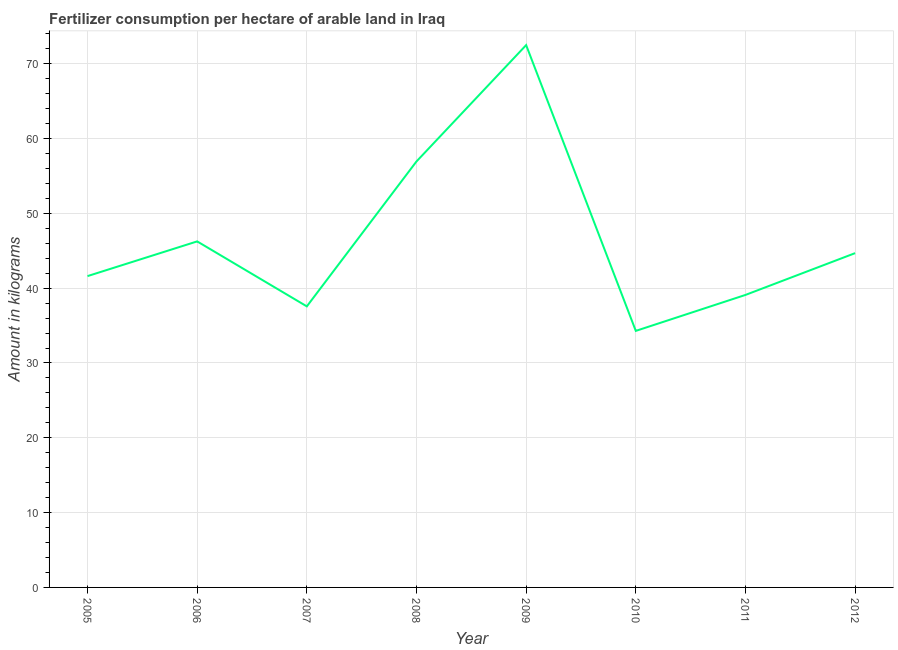What is the amount of fertilizer consumption in 2012?
Your response must be concise. 44.68. Across all years, what is the maximum amount of fertilizer consumption?
Provide a short and direct response. 72.49. Across all years, what is the minimum amount of fertilizer consumption?
Offer a terse response. 34.29. In which year was the amount of fertilizer consumption minimum?
Ensure brevity in your answer.  2010. What is the sum of the amount of fertilizer consumption?
Make the answer very short. 372.94. What is the difference between the amount of fertilizer consumption in 2008 and 2010?
Your answer should be very brief. 22.65. What is the average amount of fertilizer consumption per year?
Keep it short and to the point. 46.62. What is the median amount of fertilizer consumption?
Your response must be concise. 43.15. In how many years, is the amount of fertilizer consumption greater than 46 kg?
Provide a succinct answer. 3. What is the ratio of the amount of fertilizer consumption in 2010 to that in 2012?
Keep it short and to the point. 0.77. Is the amount of fertilizer consumption in 2005 less than that in 2010?
Your answer should be very brief. No. Is the difference between the amount of fertilizer consumption in 2006 and 2009 greater than the difference between any two years?
Your answer should be compact. No. What is the difference between the highest and the second highest amount of fertilizer consumption?
Give a very brief answer. 15.55. What is the difference between the highest and the lowest amount of fertilizer consumption?
Offer a terse response. 38.2. Does the amount of fertilizer consumption monotonically increase over the years?
Provide a succinct answer. No. How many lines are there?
Offer a very short reply. 1. What is the difference between two consecutive major ticks on the Y-axis?
Offer a very short reply. 10. Are the values on the major ticks of Y-axis written in scientific E-notation?
Make the answer very short. No. Does the graph contain any zero values?
Give a very brief answer. No. Does the graph contain grids?
Make the answer very short. Yes. What is the title of the graph?
Your answer should be compact. Fertilizer consumption per hectare of arable land in Iraq . What is the label or title of the Y-axis?
Ensure brevity in your answer.  Amount in kilograms. What is the Amount in kilograms in 2005?
Your answer should be compact. 41.61. What is the Amount in kilograms in 2006?
Keep it short and to the point. 46.25. What is the Amount in kilograms in 2007?
Offer a terse response. 37.57. What is the Amount in kilograms in 2008?
Your answer should be compact. 56.94. What is the Amount in kilograms of 2009?
Make the answer very short. 72.49. What is the Amount in kilograms of 2010?
Keep it short and to the point. 34.29. What is the Amount in kilograms in 2011?
Keep it short and to the point. 39.1. What is the Amount in kilograms in 2012?
Give a very brief answer. 44.68. What is the difference between the Amount in kilograms in 2005 and 2006?
Your response must be concise. -4.64. What is the difference between the Amount in kilograms in 2005 and 2007?
Provide a short and direct response. 4.05. What is the difference between the Amount in kilograms in 2005 and 2008?
Provide a short and direct response. -15.33. What is the difference between the Amount in kilograms in 2005 and 2009?
Your answer should be compact. -30.88. What is the difference between the Amount in kilograms in 2005 and 2010?
Provide a succinct answer. 7.32. What is the difference between the Amount in kilograms in 2005 and 2011?
Your answer should be compact. 2.52. What is the difference between the Amount in kilograms in 2005 and 2012?
Offer a very short reply. -3.07. What is the difference between the Amount in kilograms in 2006 and 2007?
Offer a very short reply. 8.69. What is the difference between the Amount in kilograms in 2006 and 2008?
Keep it short and to the point. -10.69. What is the difference between the Amount in kilograms in 2006 and 2009?
Offer a very short reply. -26.24. What is the difference between the Amount in kilograms in 2006 and 2010?
Your answer should be compact. 11.96. What is the difference between the Amount in kilograms in 2006 and 2011?
Offer a terse response. 7.16. What is the difference between the Amount in kilograms in 2006 and 2012?
Your answer should be very brief. 1.57. What is the difference between the Amount in kilograms in 2007 and 2008?
Provide a short and direct response. -19.37. What is the difference between the Amount in kilograms in 2007 and 2009?
Offer a terse response. -34.92. What is the difference between the Amount in kilograms in 2007 and 2010?
Provide a short and direct response. 3.28. What is the difference between the Amount in kilograms in 2007 and 2011?
Your answer should be very brief. -1.53. What is the difference between the Amount in kilograms in 2007 and 2012?
Ensure brevity in your answer.  -7.12. What is the difference between the Amount in kilograms in 2008 and 2009?
Give a very brief answer. -15.55. What is the difference between the Amount in kilograms in 2008 and 2010?
Offer a terse response. 22.65. What is the difference between the Amount in kilograms in 2008 and 2011?
Make the answer very short. 17.84. What is the difference between the Amount in kilograms in 2008 and 2012?
Keep it short and to the point. 12.26. What is the difference between the Amount in kilograms in 2009 and 2010?
Your answer should be compact. 38.2. What is the difference between the Amount in kilograms in 2009 and 2011?
Give a very brief answer. 33.39. What is the difference between the Amount in kilograms in 2009 and 2012?
Offer a terse response. 27.81. What is the difference between the Amount in kilograms in 2010 and 2011?
Your answer should be very brief. -4.81. What is the difference between the Amount in kilograms in 2010 and 2012?
Offer a terse response. -10.39. What is the difference between the Amount in kilograms in 2011 and 2012?
Give a very brief answer. -5.59. What is the ratio of the Amount in kilograms in 2005 to that in 2006?
Your response must be concise. 0.9. What is the ratio of the Amount in kilograms in 2005 to that in 2007?
Offer a terse response. 1.11. What is the ratio of the Amount in kilograms in 2005 to that in 2008?
Ensure brevity in your answer.  0.73. What is the ratio of the Amount in kilograms in 2005 to that in 2009?
Give a very brief answer. 0.57. What is the ratio of the Amount in kilograms in 2005 to that in 2010?
Make the answer very short. 1.21. What is the ratio of the Amount in kilograms in 2005 to that in 2011?
Offer a terse response. 1.06. What is the ratio of the Amount in kilograms in 2006 to that in 2007?
Provide a short and direct response. 1.23. What is the ratio of the Amount in kilograms in 2006 to that in 2008?
Your answer should be compact. 0.81. What is the ratio of the Amount in kilograms in 2006 to that in 2009?
Keep it short and to the point. 0.64. What is the ratio of the Amount in kilograms in 2006 to that in 2010?
Ensure brevity in your answer.  1.35. What is the ratio of the Amount in kilograms in 2006 to that in 2011?
Your answer should be compact. 1.18. What is the ratio of the Amount in kilograms in 2006 to that in 2012?
Offer a terse response. 1.03. What is the ratio of the Amount in kilograms in 2007 to that in 2008?
Give a very brief answer. 0.66. What is the ratio of the Amount in kilograms in 2007 to that in 2009?
Provide a succinct answer. 0.52. What is the ratio of the Amount in kilograms in 2007 to that in 2010?
Keep it short and to the point. 1.1. What is the ratio of the Amount in kilograms in 2007 to that in 2011?
Ensure brevity in your answer.  0.96. What is the ratio of the Amount in kilograms in 2007 to that in 2012?
Keep it short and to the point. 0.84. What is the ratio of the Amount in kilograms in 2008 to that in 2009?
Your answer should be very brief. 0.79. What is the ratio of the Amount in kilograms in 2008 to that in 2010?
Offer a terse response. 1.66. What is the ratio of the Amount in kilograms in 2008 to that in 2011?
Give a very brief answer. 1.46. What is the ratio of the Amount in kilograms in 2008 to that in 2012?
Ensure brevity in your answer.  1.27. What is the ratio of the Amount in kilograms in 2009 to that in 2010?
Your answer should be very brief. 2.11. What is the ratio of the Amount in kilograms in 2009 to that in 2011?
Give a very brief answer. 1.85. What is the ratio of the Amount in kilograms in 2009 to that in 2012?
Your answer should be compact. 1.62. What is the ratio of the Amount in kilograms in 2010 to that in 2011?
Make the answer very short. 0.88. What is the ratio of the Amount in kilograms in 2010 to that in 2012?
Keep it short and to the point. 0.77. 